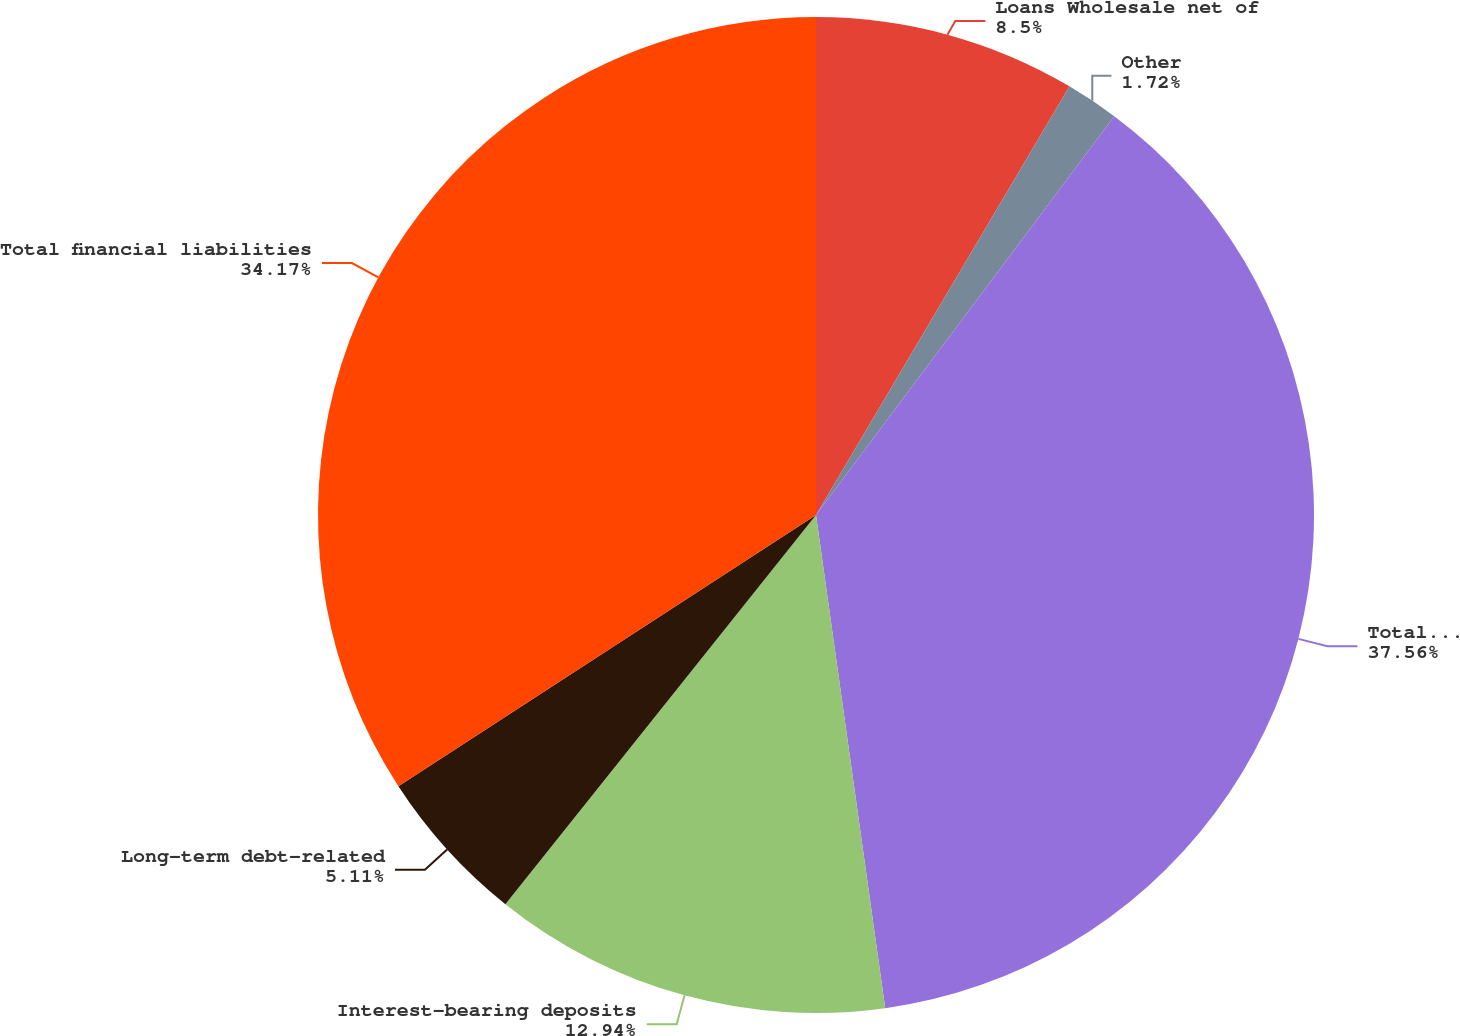Convert chart. <chart><loc_0><loc_0><loc_500><loc_500><pie_chart><fcel>Loans Wholesale net of<fcel>Other<fcel>Total financial assets<fcel>Interest-bearing deposits<fcel>Long-term debt-related<fcel>Total financial liabilities<nl><fcel>8.5%<fcel>1.72%<fcel>37.56%<fcel>12.94%<fcel>5.11%<fcel>34.17%<nl></chart> 